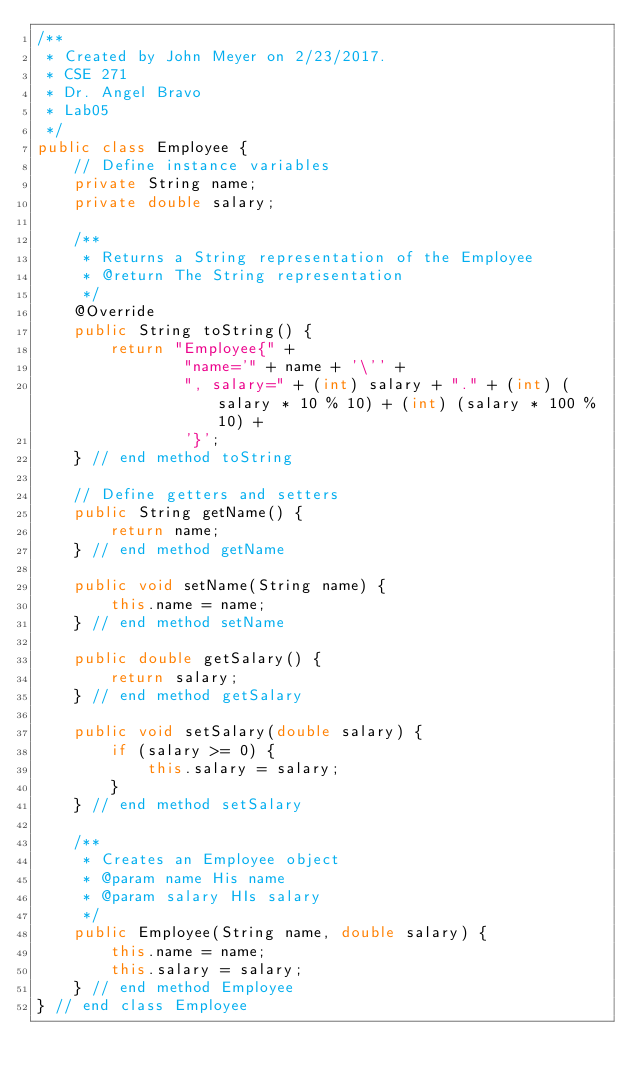<code> <loc_0><loc_0><loc_500><loc_500><_Java_>/**
 * Created by John Meyer on 2/23/2017.
 * CSE 271
 * Dr. Angel Bravo
 * Lab05
 */
public class Employee {
    // Define instance variables
    private String name;
    private double salary;

    /**
     * Returns a String representation of the Employee
     * @return The String representation
     */
    @Override
    public String toString() {
        return "Employee{" +
                "name='" + name + '\'' +
                ", salary=" + (int) salary + "." + (int) (salary * 10 % 10) + (int) (salary * 100 % 10) +
                '}';
    } // end method toString

    // Define getters and setters
    public String getName() {
        return name;
    } // end method getName

    public void setName(String name) {
        this.name = name;
    } // end method setName

    public double getSalary() {
        return salary;
    } // end method getSalary

    public void setSalary(double salary) {
        if (salary >= 0) {
            this.salary = salary;
        }
    } // end method setSalary

    /**
     * Creates an Employee object
     * @param name His name
     * @param salary HIs salary
     */
    public Employee(String name, double salary) {
        this.name = name;
        this.salary = salary;
    } // end method Employee
} // end class Employee
</code> 